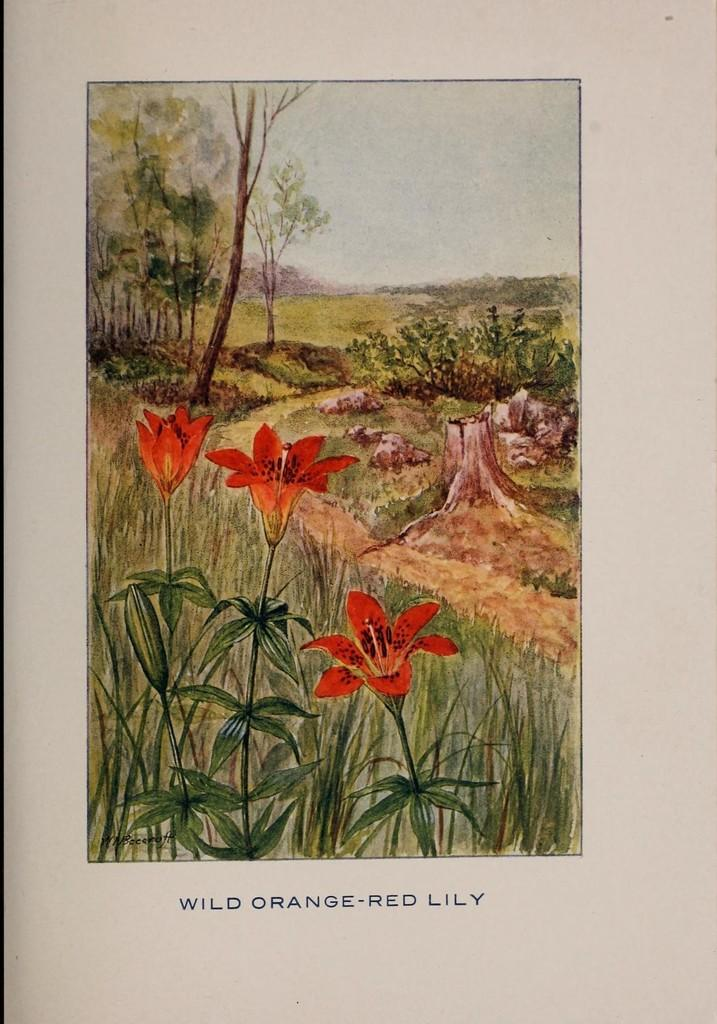What type of artwork is depicted in the image? The image is a painting. What natural elements can be seen in the painting? The painting contains flowers, plants, trees, and sky. How many dimes are scattered among the plants in the painting? There are no dimes present in the painting; it only contains natural elements such as flowers, plants, trees, and sky. 